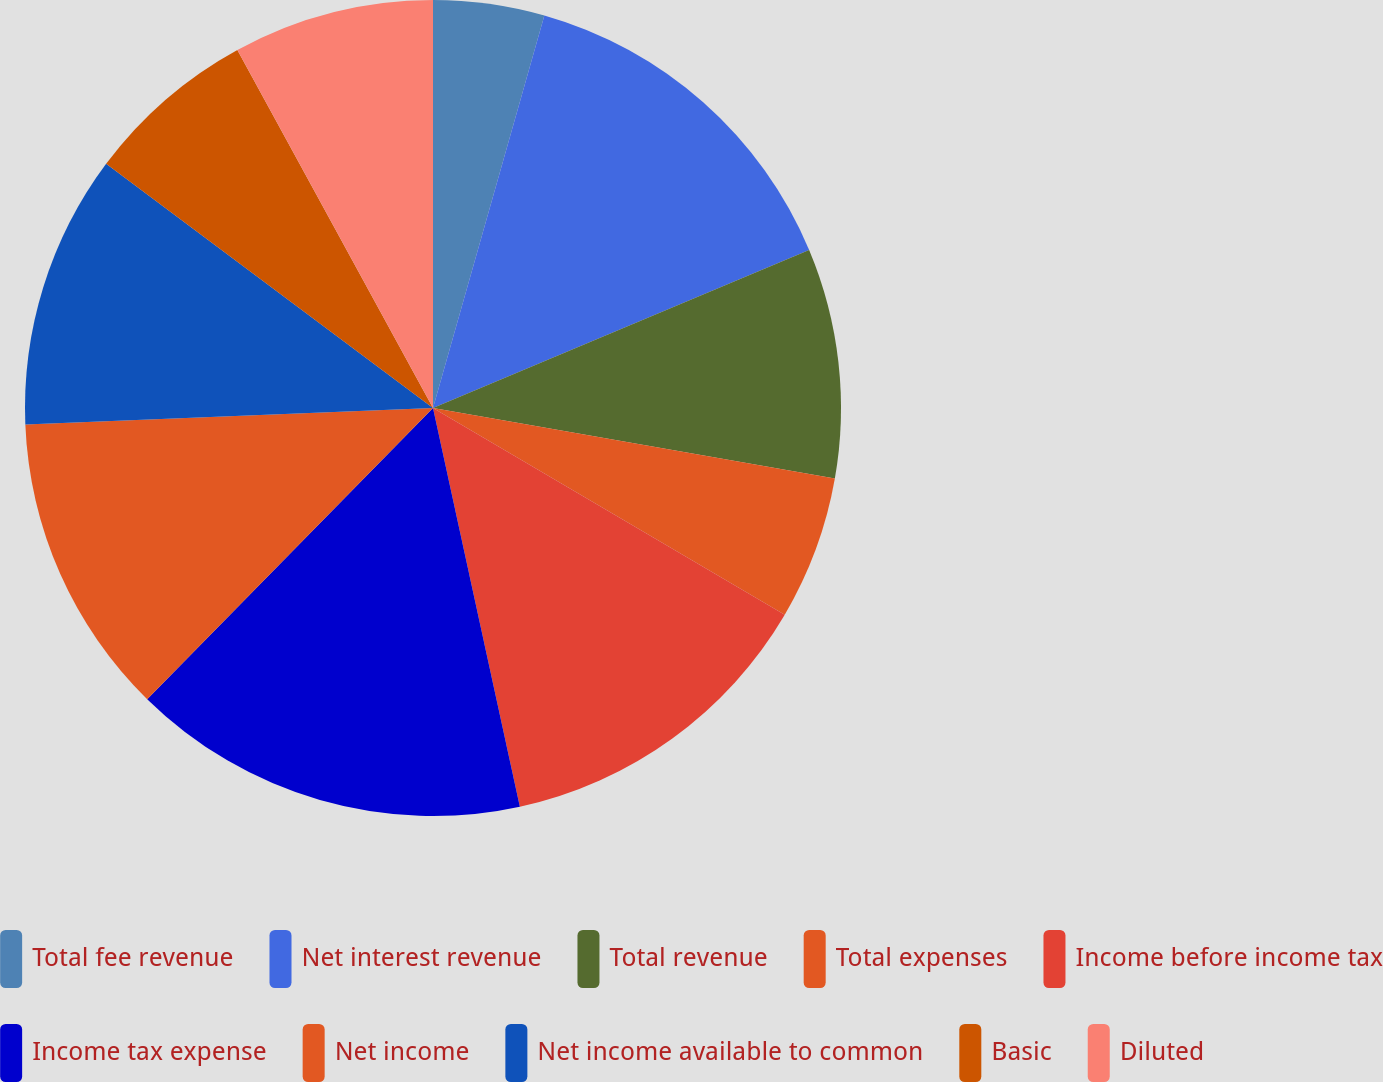<chart> <loc_0><loc_0><loc_500><loc_500><pie_chart><fcel>Total fee revenue<fcel>Net interest revenue<fcel>Total revenue<fcel>Total expenses<fcel>Income before income tax<fcel>Income tax expense<fcel>Net income<fcel>Net income available to common<fcel>Basic<fcel>Diluted<nl><fcel>4.4%<fcel>14.27%<fcel>9.1%<fcel>5.69%<fcel>13.13%<fcel>15.77%<fcel>12.0%<fcel>10.86%<fcel>6.83%<fcel>7.96%<nl></chart> 